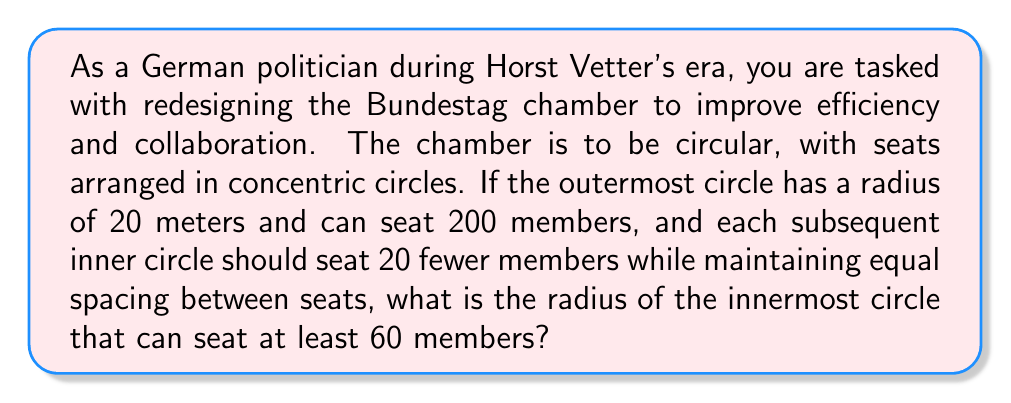Teach me how to tackle this problem. Let's approach this step-by-step:

1) First, we need to determine the number of circles and the number of seats in each circle:
   Outermost circle: 200 seats
   Second circle: 180 seats
   Third circle: 160 seats
   Fourth circle: 140 seats
   Fifth circle: 120 seats
   Sixth circle: 100 seats
   Seventh circle: 80 seats
   Eighth circle: 60 seats

2) Now, let's consider the spacing between seats. In the outermost circle:
   $$\text{Circumference} = 2\pi r = 2\pi(20) = 40\pi \text{ meters}$$
   $$\text{Space per seat} = \frac{40\pi}{200} = \frac{\pi}{5} \text{ meters}$$

3) This spacing should be maintained for all circles. For the innermost circle with 60 seats:
   $$2\pi r = 60 \cdot \frac{\pi}{5}$$
   $$r = \frac{60}{10} = 6 \text{ meters}$$

4) To verify, let's check the radii of all circles:
   $$r_n = \frac{20n}{8}, \text{ where n is the circle number from inside (1) to outside (8)}$$

   [asy]
   size(200);
   for(int i=1; i<=8; ++i) {
     draw(circle((0,0), 25*i/8), rgb(0,0,1));
   }
   [/asy]

5) We can confirm that this maintains equal spacing between seats in all circles:
   $$\text{Space per seat in any circle} = \frac{2\pi r_n}{200 - 20(8-n)} = \frac{\pi}{5} \text{ meters}$$

Therefore, the radius of the innermost circle that can seat at least 60 members is 6 meters.
Answer: 6 meters 